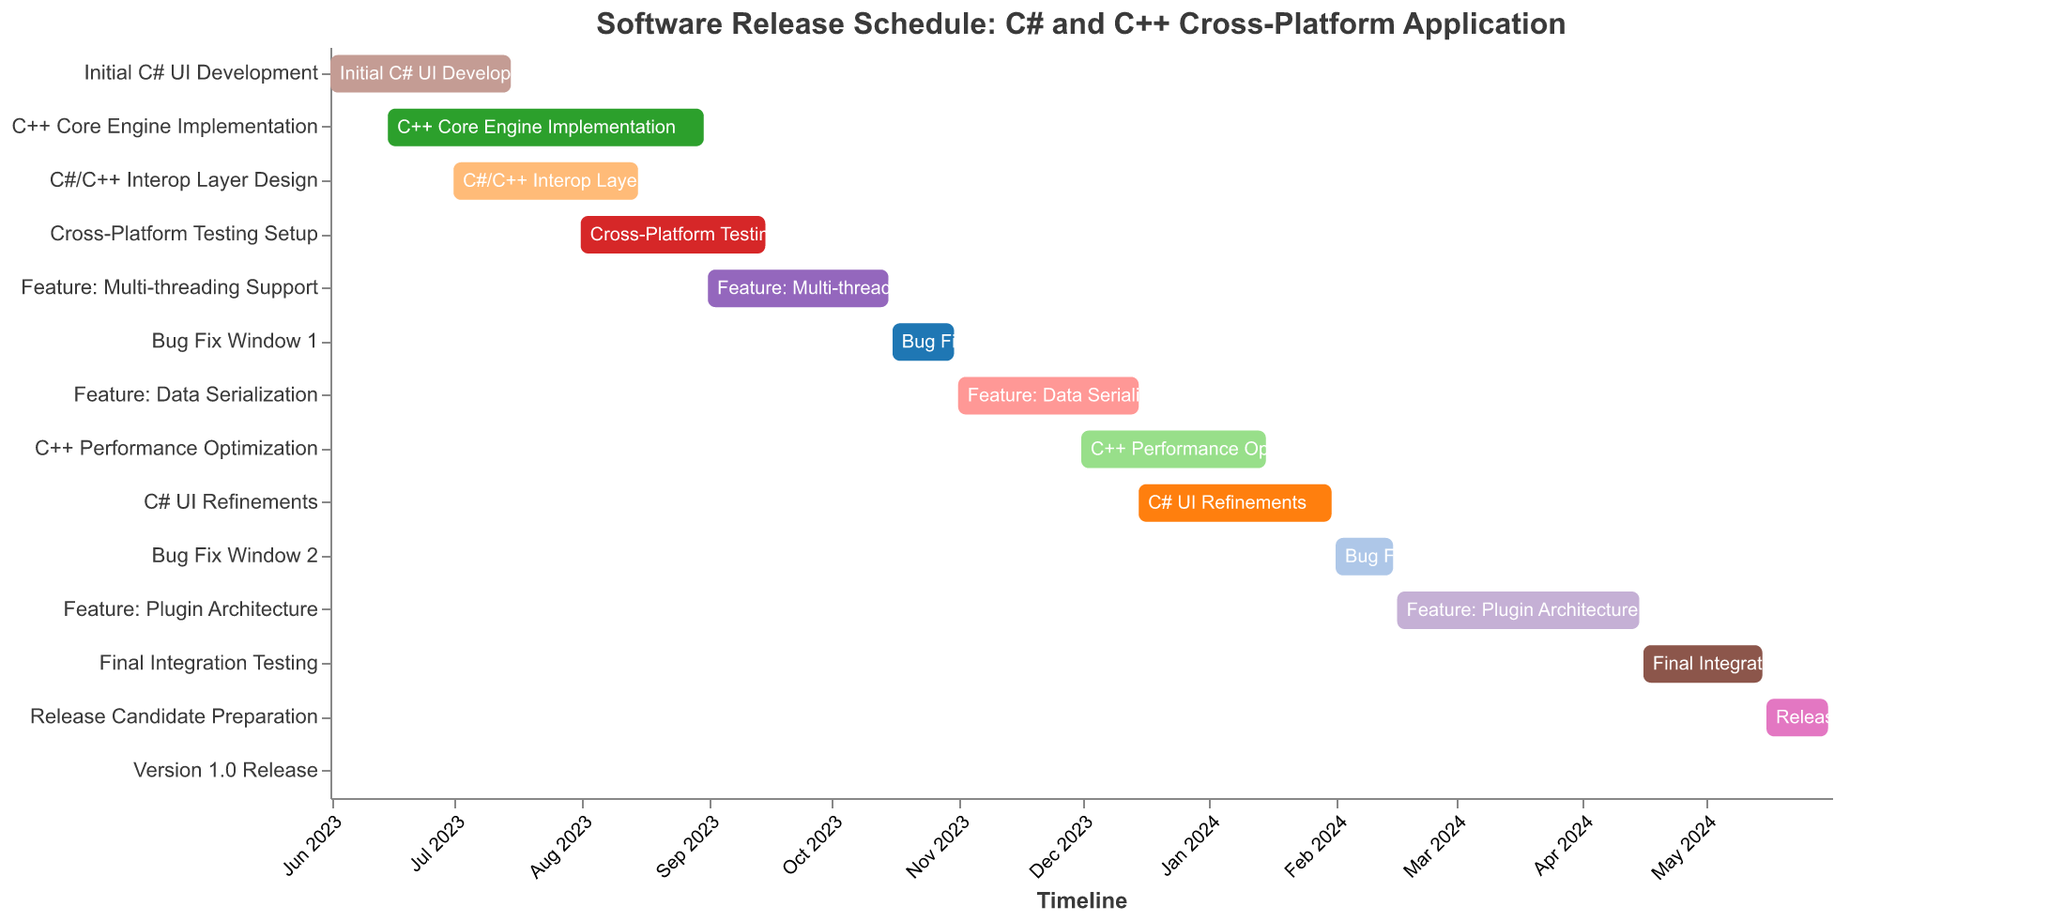Which task starts first? The Gantt chart visually represents the timeline with tasks arranged vertically. The task that starts at the earliest date on the timeline is "Initial C# UI Development".
Answer: Initial C# UI Development Which task ends last? Looking at the end dates on the right side of the Gantt chart, the task with the latest end date is "C# UI Refinements", which ends on 2024-01-31.
Answer: C# UI Refinements How long does the "C++ Core Engine Implementation" task last? The "C++ Core Engine Implementation" task starts on 2023-06-15 and ends on 2023-08-31. The number of days between these dates can be calculated.
Answer: 78 days What is the total duration of the "Bug Fix Window 1" and "Bug Fix Window 2"? "Bug Fix Window 1" lasts from 2023-10-16 to 2023-10-31 (16 days in total). "Bug Fix Window 2" lasts from 2024-02-01 to 2024-02-15 (15 days in total). Adding these durations together gives a total of 31 days.
Answer: 31 days Which tasks overlap with "C#/C++ Interop Layer Design"? The "C#/C++ Interop Layer Design" task runs from 2023-07-01 to 2023-08-15. Overlapping tasks are those that have any part of their timeline within this range: "C++ Core Engine Implementation" (2023-06-15 to 2023-08-31) and "Initial C# UI Development" (2023-06-01 to 2023-07-15).
Answer: C++ Core Engine Implementation and Initial C# UI Development What is the duration between the start of "Cross-Platform Testing Setup" and the "Version 1.0 Release"? "Cross-Platform Testing Setup" starts on 2023-08-01 and "Version 1.0 Release" occurs on 2024-06-01. To find the duration, count the number of days between these two dates.
Answer: 306 days When does the "Final Integration Testing" task occur, and how long does it last? The "Final Integration Testing" task starts on 2024-04-16 and ends on 2024-05-15. The duration is the difference between these dates.
Answer: April 16 to May 15, 30 days What tasks are scheduled to occur after "Feature: Plugin Architecture"? The tasks that occur after "Feature: Plugin Architecture" (which ends on 2024-04-15) are "Final Integration Testing", "Release Candidate Preparation", and "Version 1.0 Release".
Answer: Final Integration Testing, Release Candidate Preparation, and Version 1.0 Release 